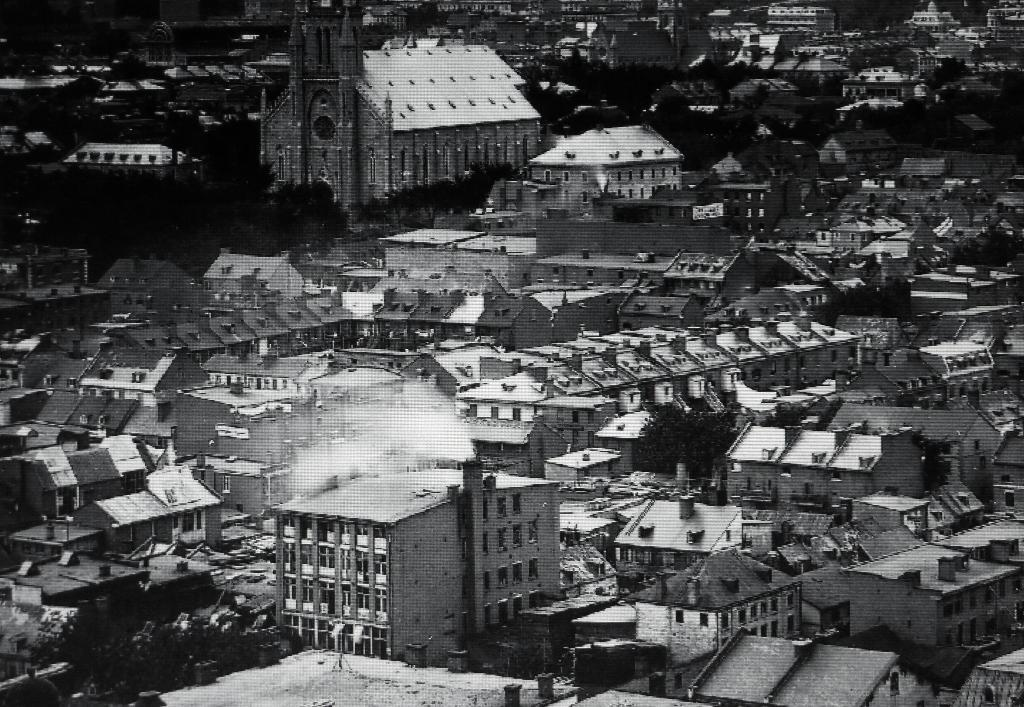What type of picture is in the image? The image contains a black and white picture. What is the subject of the picture? The picture depicts a group of buildings. What features can be observed on the buildings? The buildings have windows and roofs. What other elements are present in the image? There are trees present in the image. What brand of toothpaste is being advertised in the image? There is no toothpaste or advertisement present in the image; it features a black and white picture of a group of buildings. What class of buildings is depicted in the image? The image does not specify the class of buildings; it simply shows a group of buildings with windows and roofs. 